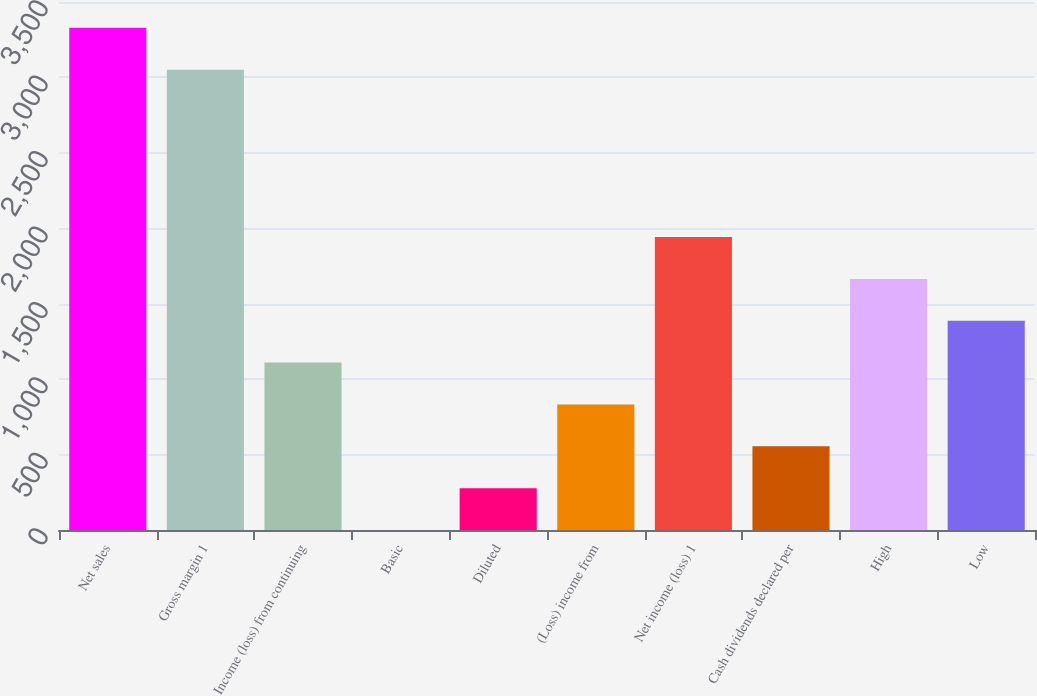Convert chart to OTSL. <chart><loc_0><loc_0><loc_500><loc_500><bar_chart><fcel>Net sales<fcel>Gross margin 1<fcel>Income (loss) from continuing<fcel>Basic<fcel>Diluted<fcel>(Loss) income from<fcel>Net income (loss) 1<fcel>Cash dividends declared per<fcel>High<fcel>Low<nl><fcel>3328.79<fcel>3051.4<fcel>1109.67<fcel>0.11<fcel>277.5<fcel>832.28<fcel>1941.84<fcel>554.89<fcel>1664.45<fcel>1387.06<nl></chart> 